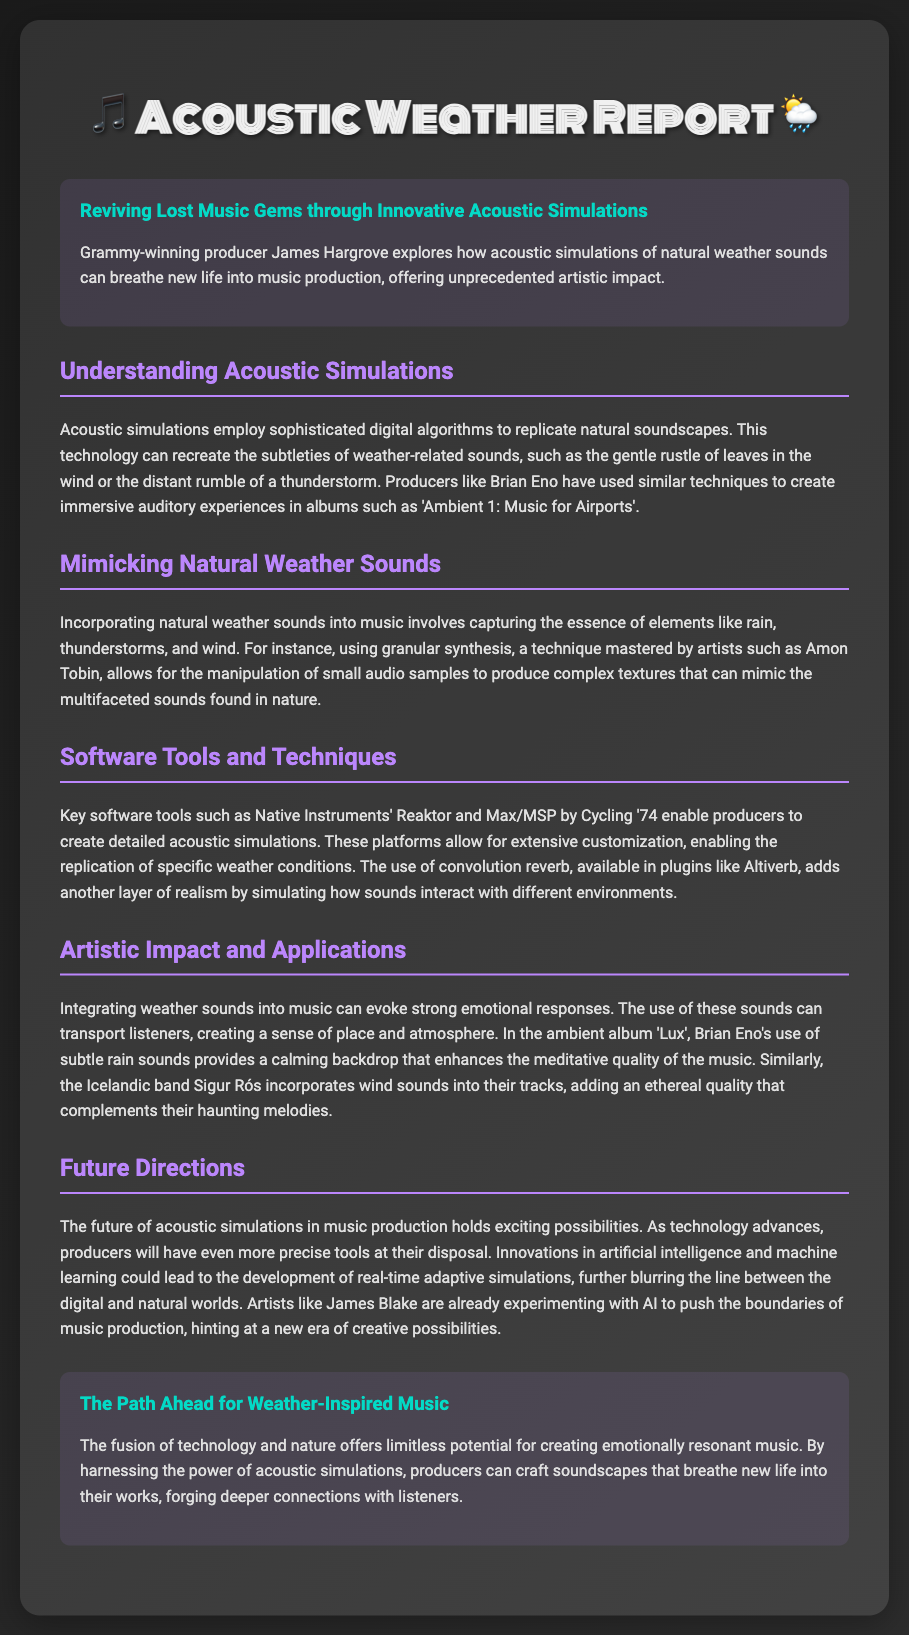What is the title of the report? The title of the report is mentioned in the header of the document.
Answer: Acoustic Weather Report Who is the producer mentioned in the introduction? The introduction highlights a specific producer involved with the topic.
Answer: James Hargrove Which software enables producers to create detailed acoustic simulations? The section on software tools lists specific platforms that facilitate simulations.
Answer: Native Instruments' Reaktor What technique is used to manipulate small audio samples? The section on mimicking natural weather sounds explains a specific technique used by artists.
Answer: Granular synthesis What emotional effect can integrating weather sounds into music have? In the section discussing artistic impact, the emotional response of listeners to weather sounds is addressed.
Answer: Strong emotional responses What does Brian Eno's album 'Lux' incorporate to enhance its meditative quality? The section on artistic impact describes specific sounds used in Brian Eno's album.
Answer: Subtle rain sounds What advances are predicted for the future of acoustic simulations in music production? The future directions section discusses the expected innovations in technology related to simulations.
Answer: Real-time adaptive simulations Which artist is mentioned as experimenting with AI in music production? The future directions section highlights a specific artist pushing creative boundaries.
Answer: James Blake 